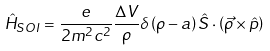Convert formula to latex. <formula><loc_0><loc_0><loc_500><loc_500>\hat { H } _ { S O I } = \frac { e } { 2 m ^ { 2 } c ^ { 2 } } \frac { \Delta V } { \rho } \delta \left ( \rho - a \right ) \hat { S } \cdot \left ( \vec { \rho } \times \hat { p } \right )</formula> 